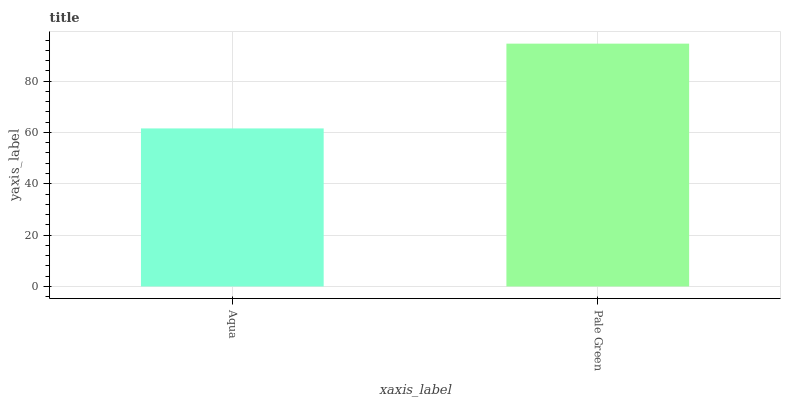Is Aqua the minimum?
Answer yes or no. Yes. Is Pale Green the maximum?
Answer yes or no. Yes. Is Pale Green the minimum?
Answer yes or no. No. Is Pale Green greater than Aqua?
Answer yes or no. Yes. Is Aqua less than Pale Green?
Answer yes or no. Yes. Is Aqua greater than Pale Green?
Answer yes or no. No. Is Pale Green less than Aqua?
Answer yes or no. No. Is Pale Green the high median?
Answer yes or no. Yes. Is Aqua the low median?
Answer yes or no. Yes. Is Aqua the high median?
Answer yes or no. No. Is Pale Green the low median?
Answer yes or no. No. 